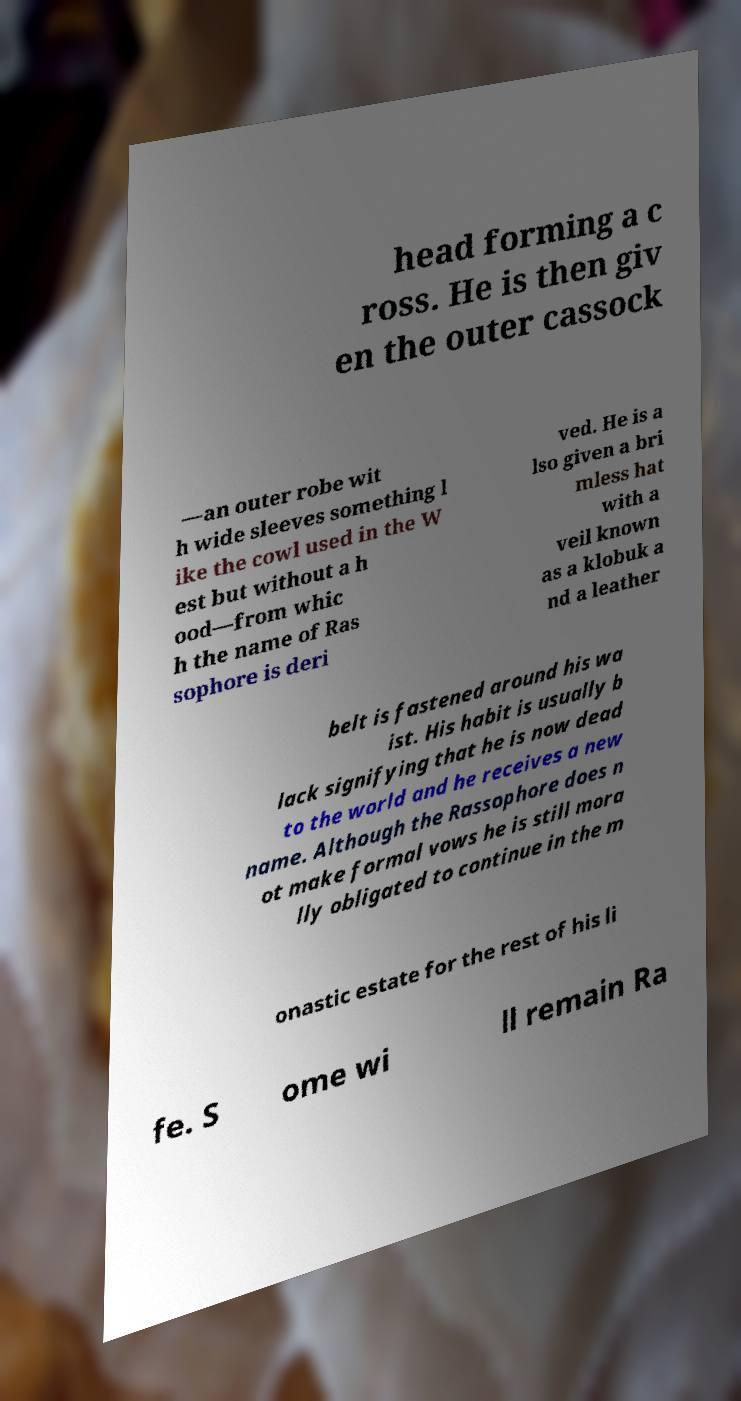Please read and relay the text visible in this image. What does it say? head forming a c ross. He is then giv en the outer cassock —an outer robe wit h wide sleeves something l ike the cowl used in the W est but without a h ood—from whic h the name of Ras sophore is deri ved. He is a lso given a bri mless hat with a veil known as a klobuk a nd a leather belt is fastened around his wa ist. His habit is usually b lack signifying that he is now dead to the world and he receives a new name. Although the Rassophore does n ot make formal vows he is still mora lly obligated to continue in the m onastic estate for the rest of his li fe. S ome wi ll remain Ra 